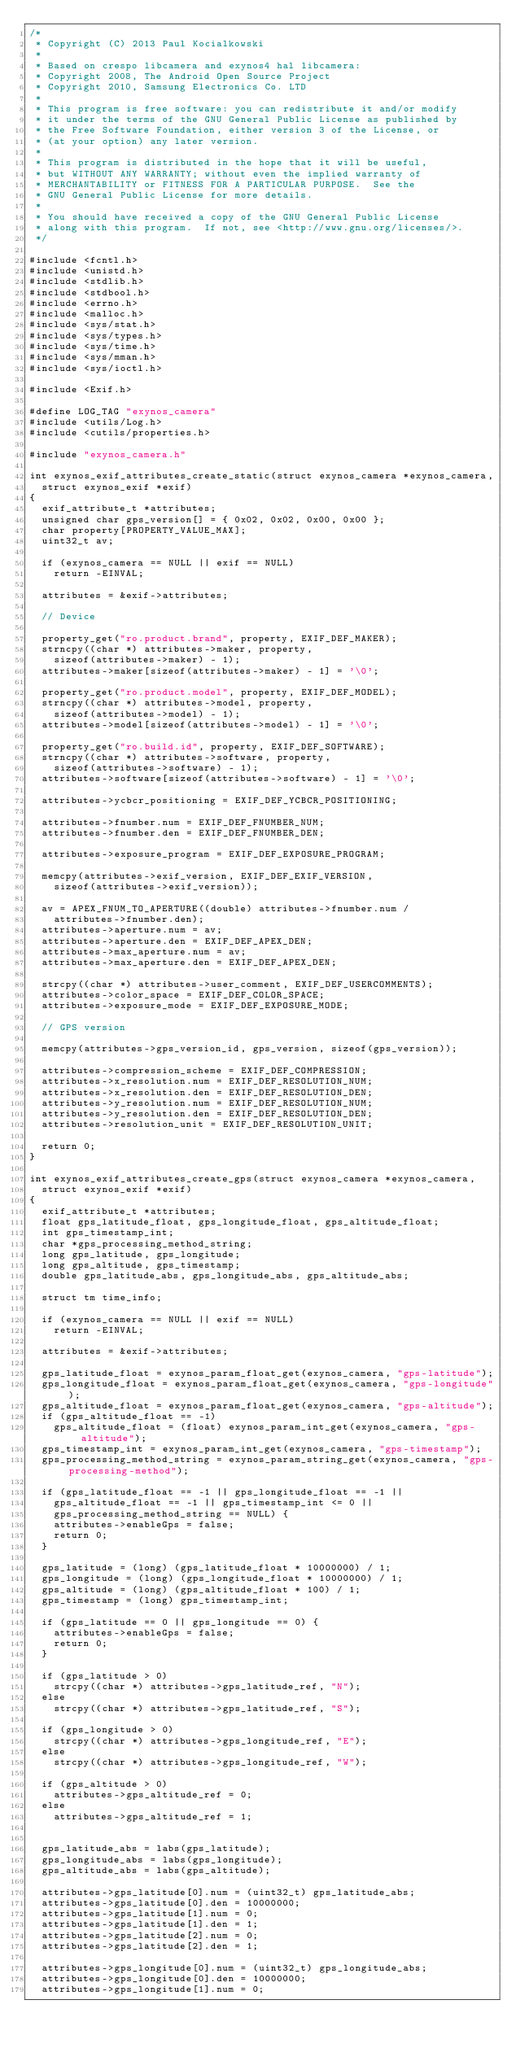Convert code to text. <code><loc_0><loc_0><loc_500><loc_500><_C_>/*
 * Copyright (C) 2013 Paul Kocialkowski
 *
 * Based on crespo libcamera and exynos4 hal libcamera:
 * Copyright 2008, The Android Open Source Project
 * Copyright 2010, Samsung Electronics Co. LTD
 *
 * This program is free software: you can redistribute it and/or modify
 * it under the terms of the GNU General Public License as published by
 * the Free Software Foundation, either version 3 of the License, or
 * (at your option) any later version.
 *
 * This program is distributed in the hope that it will be useful,
 * but WITHOUT ANY WARRANTY; without even the implied warranty of
 * MERCHANTABILITY or FITNESS FOR A PARTICULAR PURPOSE.  See the
 * GNU General Public License for more details.
 *
 * You should have received a copy of the GNU General Public License
 * along with this program.  If not, see <http://www.gnu.org/licenses/>.
 */

#include <fcntl.h>
#include <unistd.h>
#include <stdlib.h>
#include <stdbool.h>
#include <errno.h>
#include <malloc.h>
#include <sys/stat.h>
#include <sys/types.h>
#include <sys/time.h>
#include <sys/mman.h>
#include <sys/ioctl.h>

#include <Exif.h>

#define LOG_TAG "exynos_camera"
#include <utils/Log.h>
#include <cutils/properties.h>

#include "exynos_camera.h"

int exynos_exif_attributes_create_static(struct exynos_camera *exynos_camera,
	struct exynos_exif *exif)
{
	exif_attribute_t *attributes;
	unsigned char gps_version[] = { 0x02, 0x02, 0x00, 0x00 };
	char property[PROPERTY_VALUE_MAX];
	uint32_t av;

	if (exynos_camera == NULL || exif == NULL)
		return -EINVAL;

	attributes = &exif->attributes;

	// Device

	property_get("ro.product.brand", property, EXIF_DEF_MAKER);
	strncpy((char *) attributes->maker, property,
		sizeof(attributes->maker) - 1);
	attributes->maker[sizeof(attributes->maker) - 1] = '\0';

	property_get("ro.product.model", property, EXIF_DEF_MODEL);
	strncpy((char *) attributes->model, property,
		sizeof(attributes->model) - 1);
	attributes->model[sizeof(attributes->model) - 1] = '\0';

	property_get("ro.build.id", property, EXIF_DEF_SOFTWARE);
	strncpy((char *) attributes->software, property,
		sizeof(attributes->software) - 1);
	attributes->software[sizeof(attributes->software) - 1] = '\0';

	attributes->ycbcr_positioning = EXIF_DEF_YCBCR_POSITIONING;

	attributes->fnumber.num = EXIF_DEF_FNUMBER_NUM;
	attributes->fnumber.den = EXIF_DEF_FNUMBER_DEN;

	attributes->exposure_program = EXIF_DEF_EXPOSURE_PROGRAM;

	memcpy(attributes->exif_version, EXIF_DEF_EXIF_VERSION,
		sizeof(attributes->exif_version));

	av = APEX_FNUM_TO_APERTURE((double) attributes->fnumber.num /
		attributes->fnumber.den);
	attributes->aperture.num = av;
	attributes->aperture.den = EXIF_DEF_APEX_DEN;
	attributes->max_aperture.num = av;
	attributes->max_aperture.den = EXIF_DEF_APEX_DEN;

	strcpy((char *) attributes->user_comment, EXIF_DEF_USERCOMMENTS);
	attributes->color_space = EXIF_DEF_COLOR_SPACE;
	attributes->exposure_mode = EXIF_DEF_EXPOSURE_MODE;

	// GPS version

	memcpy(attributes->gps_version_id, gps_version, sizeof(gps_version));

	attributes->compression_scheme = EXIF_DEF_COMPRESSION;
	attributes->x_resolution.num = EXIF_DEF_RESOLUTION_NUM;
	attributes->x_resolution.den = EXIF_DEF_RESOLUTION_DEN;
	attributes->y_resolution.num = EXIF_DEF_RESOLUTION_NUM;
	attributes->y_resolution.den = EXIF_DEF_RESOLUTION_DEN;
	attributes->resolution_unit = EXIF_DEF_RESOLUTION_UNIT;

	return 0;
}

int exynos_exif_attributes_create_gps(struct exynos_camera *exynos_camera,
	struct exynos_exif *exif)
{
	exif_attribute_t *attributes;
	float gps_latitude_float, gps_longitude_float, gps_altitude_float;
	int gps_timestamp_int;
	char *gps_processing_method_string;
	long gps_latitude, gps_longitude;
	long gps_altitude, gps_timestamp;
	double gps_latitude_abs, gps_longitude_abs, gps_altitude_abs;

	struct tm time_info;

	if (exynos_camera == NULL || exif == NULL)
		return -EINVAL;

	attributes = &exif->attributes;

	gps_latitude_float = exynos_param_float_get(exynos_camera, "gps-latitude");
	gps_longitude_float = exynos_param_float_get(exynos_camera, "gps-longitude");
	gps_altitude_float = exynos_param_float_get(exynos_camera, "gps-altitude");
	if (gps_altitude_float == -1)
		gps_altitude_float = (float) exynos_param_int_get(exynos_camera, "gps-altitude");
	gps_timestamp_int = exynos_param_int_get(exynos_camera, "gps-timestamp");
	gps_processing_method_string = exynos_param_string_get(exynos_camera, "gps-processing-method");

	if (gps_latitude_float == -1 || gps_longitude_float == -1 ||
		gps_altitude_float == -1 || gps_timestamp_int <= 0 ||
		gps_processing_method_string == NULL) {
		attributes->enableGps = false;
		return 0;
	}

	gps_latitude = (long) (gps_latitude_float * 10000000) / 1;
	gps_longitude = (long) (gps_longitude_float * 10000000) / 1;
	gps_altitude = (long) (gps_altitude_float * 100) / 1;
	gps_timestamp = (long) gps_timestamp_int;

	if (gps_latitude == 0 || gps_longitude == 0) {
		attributes->enableGps = false;
		return 0;
	}

	if (gps_latitude > 0)
		strcpy((char *) attributes->gps_latitude_ref, "N");
	else
		strcpy((char *) attributes->gps_latitude_ref, "S");

	if (gps_longitude > 0)
		strcpy((char *) attributes->gps_longitude_ref, "E");
	else
		strcpy((char *) attributes->gps_longitude_ref, "W");

	if (gps_altitude > 0)
		attributes->gps_altitude_ref = 0;
	else
		attributes->gps_altitude_ref = 1;


	gps_latitude_abs = labs(gps_latitude);
	gps_longitude_abs = labs(gps_longitude);
	gps_altitude_abs = labs(gps_altitude);

	attributes->gps_latitude[0].num = (uint32_t) gps_latitude_abs;
	attributes->gps_latitude[0].den = 10000000;
	attributes->gps_latitude[1].num = 0;
	attributes->gps_latitude[1].den = 1;
	attributes->gps_latitude[2].num = 0;
	attributes->gps_latitude[2].den = 1;

	attributes->gps_longitude[0].num = (uint32_t) gps_longitude_abs;
	attributes->gps_longitude[0].den = 10000000;
	attributes->gps_longitude[1].num = 0;</code> 